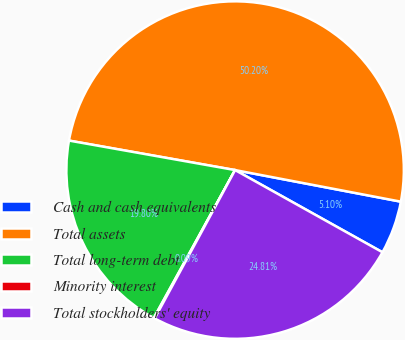Convert chart to OTSL. <chart><loc_0><loc_0><loc_500><loc_500><pie_chart><fcel>Cash and cash equivalents<fcel>Total assets<fcel>Total long-term debt<fcel>Minority interest<fcel>Total stockholders' equity<nl><fcel>5.1%<fcel>50.2%<fcel>19.8%<fcel>0.09%<fcel>24.81%<nl></chart> 